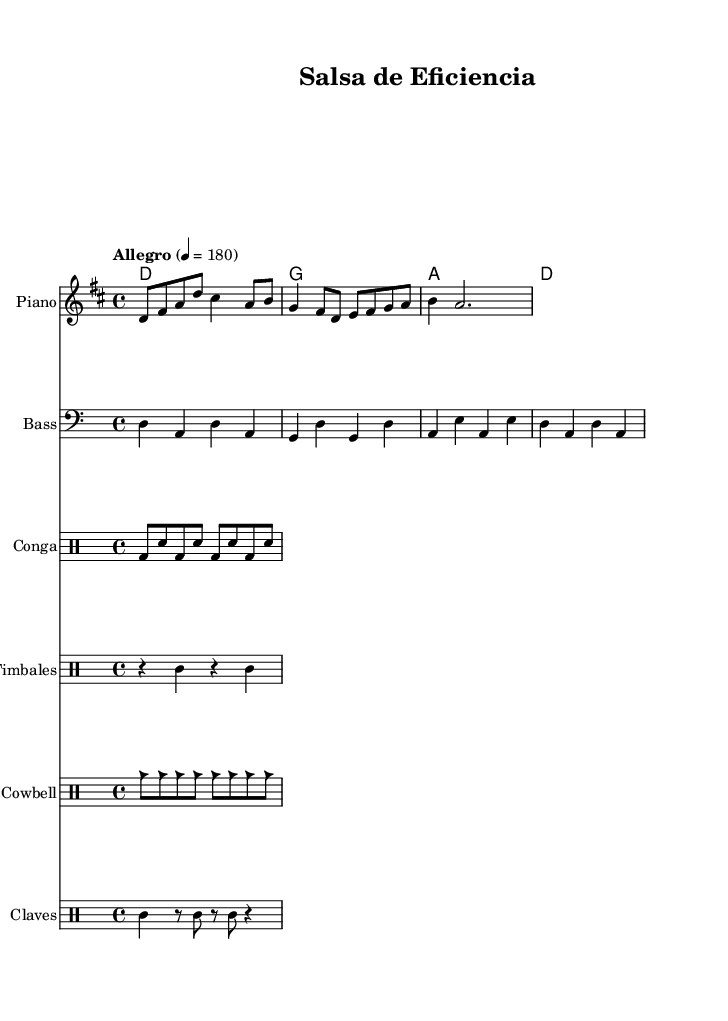What is the key signature of this music? The key signature is indicated at the beginning of the staff with one sharp, which corresponds to D major.
Answer: D major What is the time signature of this piece? The time signature is indicated at the beginning of the staff and shows four beats per measure. The "4/4" designation indicates that there are four quarter-note beats in each measure.
Answer: 4/4 What is the tempo marking of the piece? The tempo marking is found above the staff and indicates that the piece should be played at a speed of 180 beats per minute, described as "Allegro."
Answer: Allegro 4 = 180 How many measures are in the melody part? By counting the individual measures notated in the melody staff, we can determine that there are four measures total in the provided melody.
Answer: 4 What percussion instruments are featured in this music? The percussion sections list three distinct types of instruments: Congas, Timbales, and Cowbell, each represented in separate drum staffs.
Answer: Congas, Timbales, Cowbell What type of rhythm pattern is primarily used in the congas? The rhythm pattern provided in the congas section shows a consistent alternating pattern of bass and snare hits, creating a traditional salsa groove.
Answer: Bass and snare What is the role of the claves in this piece? The claves are shown playing a specific rhythm pattern that adds syncopation and accents to the music, and they serve as an important structural element in Latin music styles.
Answer: Syncopation 